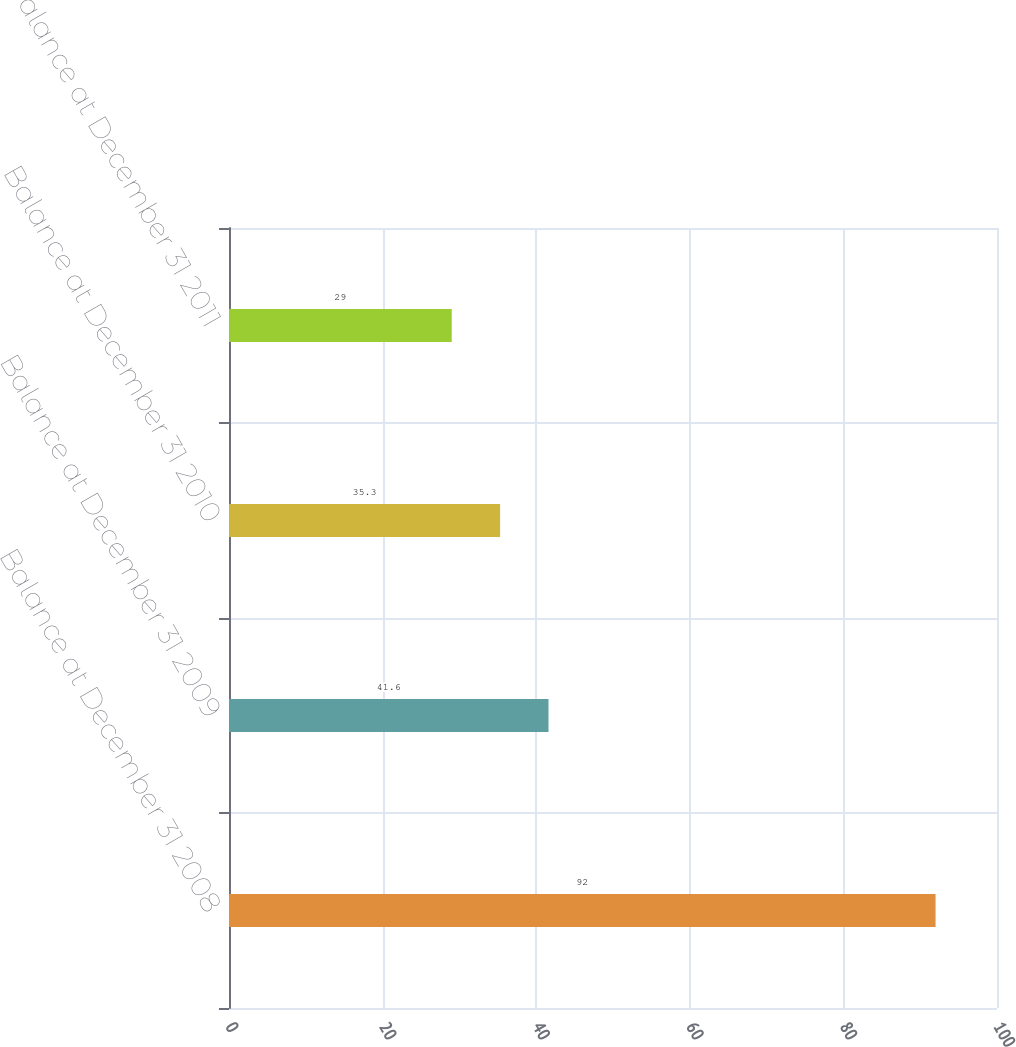Convert chart. <chart><loc_0><loc_0><loc_500><loc_500><bar_chart><fcel>Balance at December 31 2008<fcel>Balance at December 31 2009<fcel>Balance at December 31 2010<fcel>Balance at December 31 2011<nl><fcel>92<fcel>41.6<fcel>35.3<fcel>29<nl></chart> 